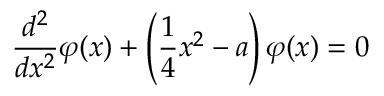<formula> <loc_0><loc_0><loc_500><loc_500>\frac { d ^ { 2 } } { d x ^ { 2 } } \varphi ( x ) + \left ( \frac { 1 } { 4 } x ^ { 2 } - a \right ) \varphi ( x ) = 0</formula> 